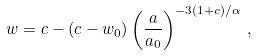<formula> <loc_0><loc_0><loc_500><loc_500>w = c - ( c - w _ { 0 } ) \left ( \frac { a } { a _ { 0 } } \right ) ^ { - 3 ( 1 + c ) / \alpha } \, ,</formula> 